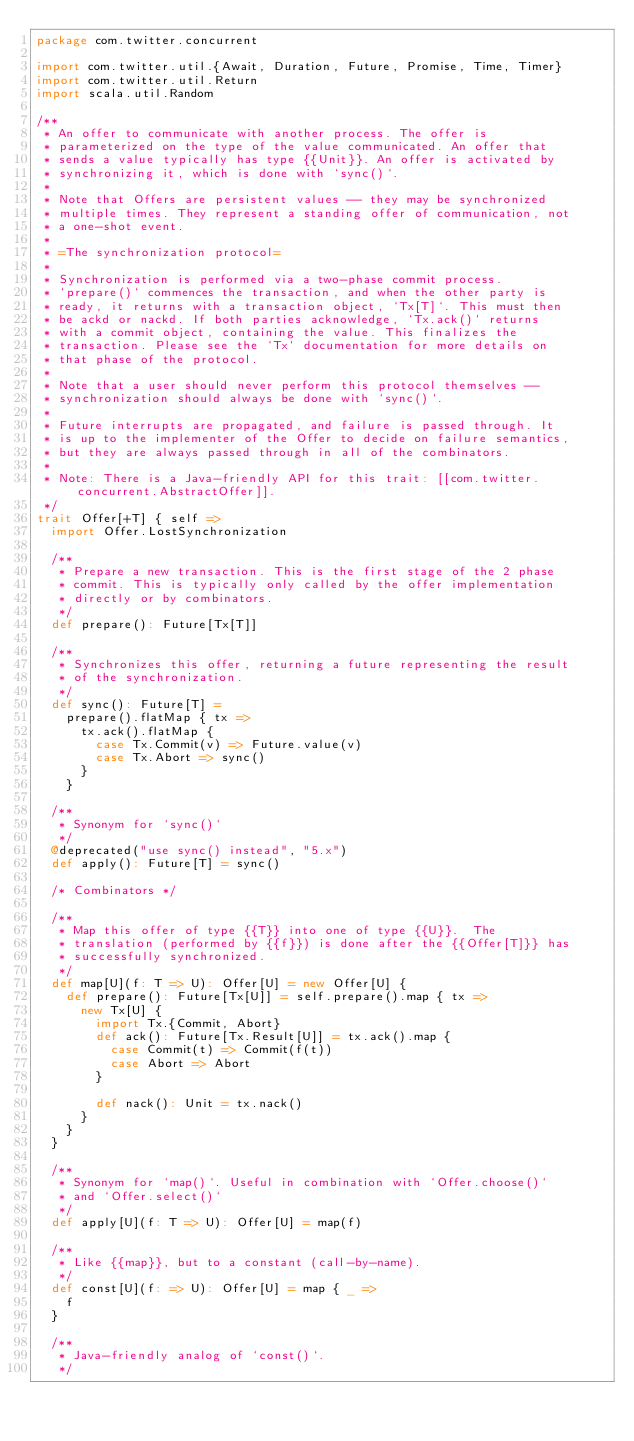Convert code to text. <code><loc_0><loc_0><loc_500><loc_500><_Scala_>package com.twitter.concurrent

import com.twitter.util.{Await, Duration, Future, Promise, Time, Timer}
import com.twitter.util.Return
import scala.util.Random

/**
 * An offer to communicate with another process. The offer is
 * parameterized on the type of the value communicated. An offer that
 * sends a value typically has type {{Unit}}. An offer is activated by
 * synchronizing it, which is done with `sync()`.
 *
 * Note that Offers are persistent values -- they may be synchronized
 * multiple times. They represent a standing offer of communication, not
 * a one-shot event.
 *
 * =The synchronization protocol=
 *
 * Synchronization is performed via a two-phase commit process.
 * `prepare()` commences the transaction, and when the other party is
 * ready, it returns with a transaction object, `Tx[T]`. This must then
 * be ackd or nackd. If both parties acknowledge, `Tx.ack()` returns
 * with a commit object, containing the value. This finalizes the
 * transaction. Please see the `Tx` documentation for more details on
 * that phase of the protocol.
 *
 * Note that a user should never perform this protocol themselves --
 * synchronization should always be done with `sync()`.
 *
 * Future interrupts are propagated, and failure is passed through. It
 * is up to the implementer of the Offer to decide on failure semantics,
 * but they are always passed through in all of the combinators.
 *
 * Note: There is a Java-friendly API for this trait: [[com.twitter.concurrent.AbstractOffer]].
 */
trait Offer[+T] { self =>
  import Offer.LostSynchronization

  /**
   * Prepare a new transaction. This is the first stage of the 2 phase
   * commit. This is typically only called by the offer implementation
   * directly or by combinators.
   */
  def prepare(): Future[Tx[T]]

  /**
   * Synchronizes this offer, returning a future representing the result
   * of the synchronization.
   */
  def sync(): Future[T] =
    prepare().flatMap { tx =>
      tx.ack().flatMap {
        case Tx.Commit(v) => Future.value(v)
        case Tx.Abort => sync()
      }
    }

  /**
   * Synonym for `sync()`
   */
  @deprecated("use sync() instead", "5.x")
  def apply(): Future[T] = sync()

  /* Combinators */

  /**
   * Map this offer of type {{T}} into one of type {{U}}.  The
   * translation (performed by {{f}}) is done after the {{Offer[T]}} has
   * successfully synchronized.
   */
  def map[U](f: T => U): Offer[U] = new Offer[U] {
    def prepare(): Future[Tx[U]] = self.prepare().map { tx =>
      new Tx[U] {
        import Tx.{Commit, Abort}
        def ack(): Future[Tx.Result[U]] = tx.ack().map {
          case Commit(t) => Commit(f(t))
          case Abort => Abort
        }

        def nack(): Unit = tx.nack()
      }
    }
  }

  /**
   * Synonym for `map()`. Useful in combination with `Offer.choose()`
   * and `Offer.select()`
   */
  def apply[U](f: T => U): Offer[U] = map(f)

  /**
   * Like {{map}}, but to a constant (call-by-name).
   */
  def const[U](f: => U): Offer[U] = map { _ =>
    f
  }

  /**
   * Java-friendly analog of `const()`.
   */</code> 